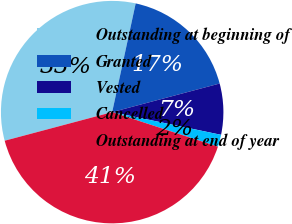Convert chart to OTSL. <chart><loc_0><loc_0><loc_500><loc_500><pie_chart><fcel>Outstanding at beginning of<fcel>Granted<fcel>Vested<fcel>Cancelled<fcel>Outstanding at end of year<nl><fcel>32.53%<fcel>17.47%<fcel>7.41%<fcel>1.76%<fcel>40.83%<nl></chart> 